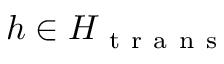<formula> <loc_0><loc_0><loc_500><loc_500>h \in H _ { t r a n s }</formula> 